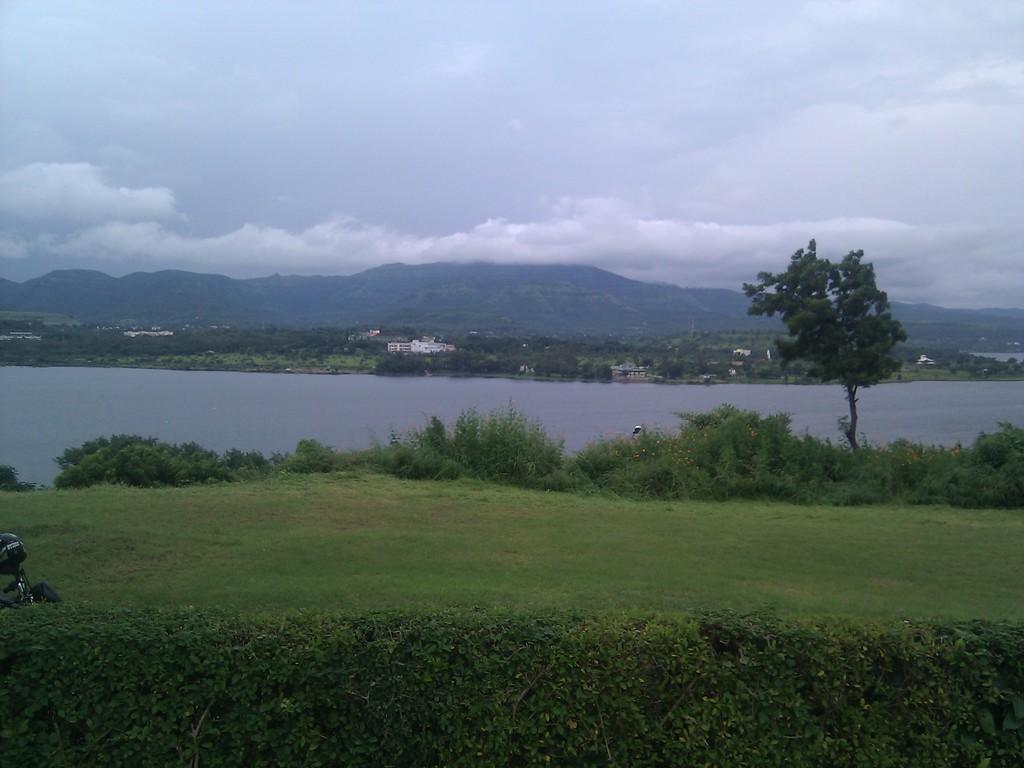Could you give a brief overview of what you see in this image? In this picture I can see the bushes at the bottom, in the middle there is water, in the background there are trees and hills. At the top I can see the sky, on the left side it looks like a helmet on the vehicle. 